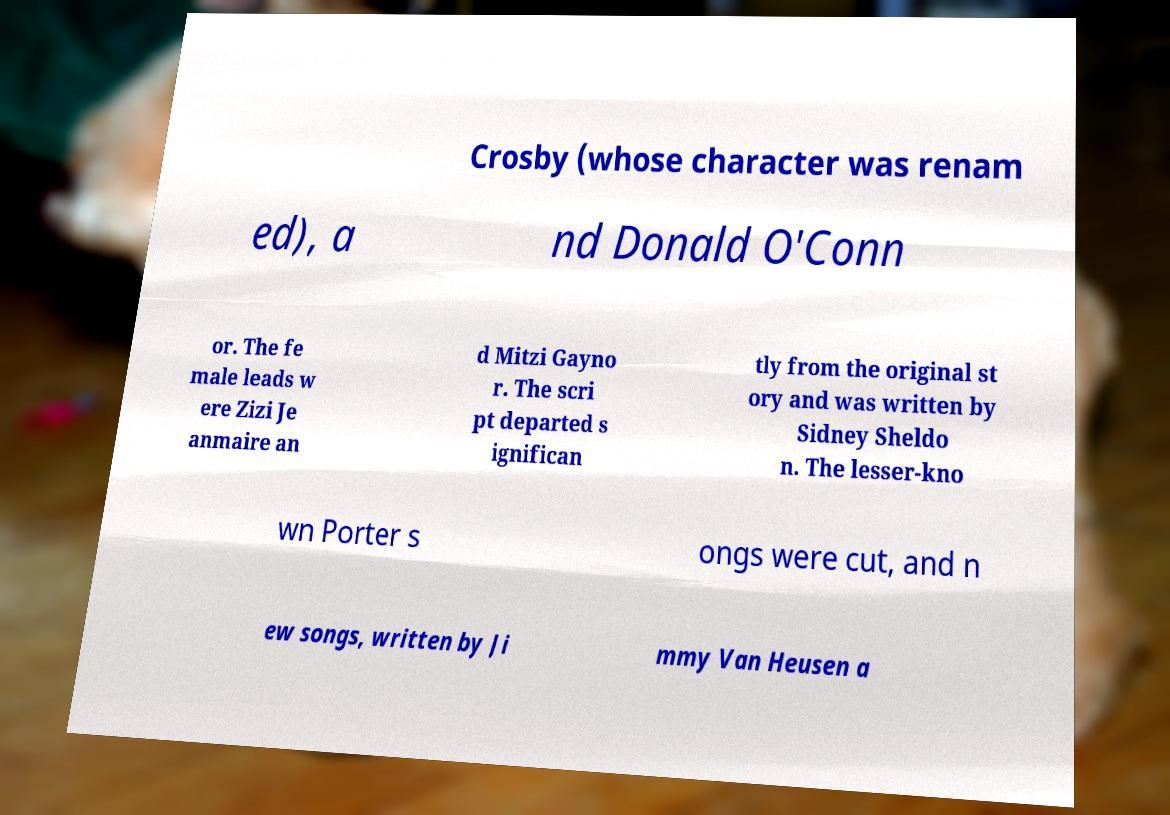There's text embedded in this image that I need extracted. Can you transcribe it verbatim? Crosby (whose character was renam ed), a nd Donald O'Conn or. The fe male leads w ere Zizi Je anmaire an d Mitzi Gayno r. The scri pt departed s ignifican tly from the original st ory and was written by Sidney Sheldo n. The lesser-kno wn Porter s ongs were cut, and n ew songs, written by Ji mmy Van Heusen a 